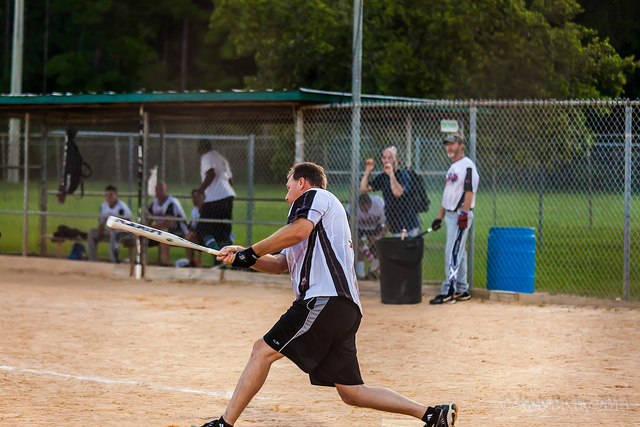<image>What color is the batter's helmet? The batter is not wearing a helmet in the image. What color is the batter's helmet? There is no batter's helmet in the image. 